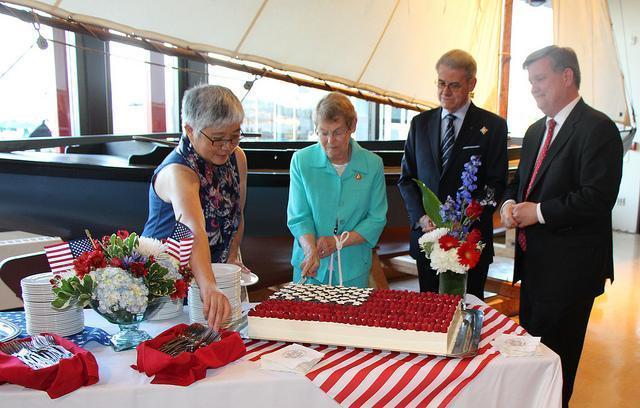Does the description: "The boat is at the left side of the dining table." accurately reflect the image?
Answer yes or no. No. 